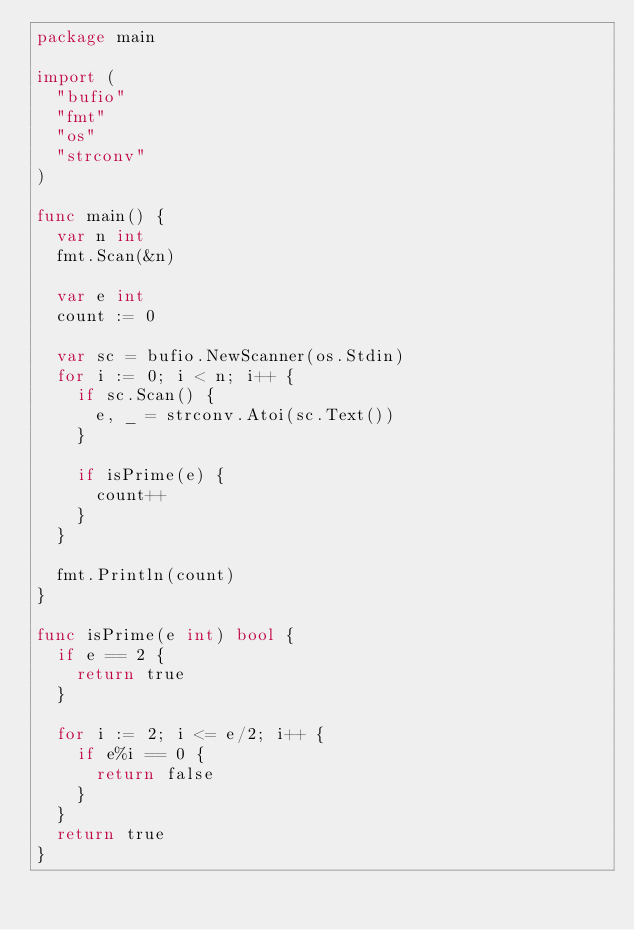Convert code to text. <code><loc_0><loc_0><loc_500><loc_500><_Go_>package main

import (
	"bufio"
	"fmt"
	"os"
	"strconv"
)

func main() {
	var n int
	fmt.Scan(&n)

	var e int
	count := 0

	var sc = bufio.NewScanner(os.Stdin)
	for i := 0; i < n; i++ {
		if sc.Scan() {
			e, _ = strconv.Atoi(sc.Text())
		}

		if isPrime(e) {
			count++
		}
	}

	fmt.Println(count)
}

func isPrime(e int) bool {
	if e == 2 {
		return true
	}

	for i := 2; i <= e/2; i++ {
		if e%i == 0 {
			return false
		}
	}
	return true
}

</code> 